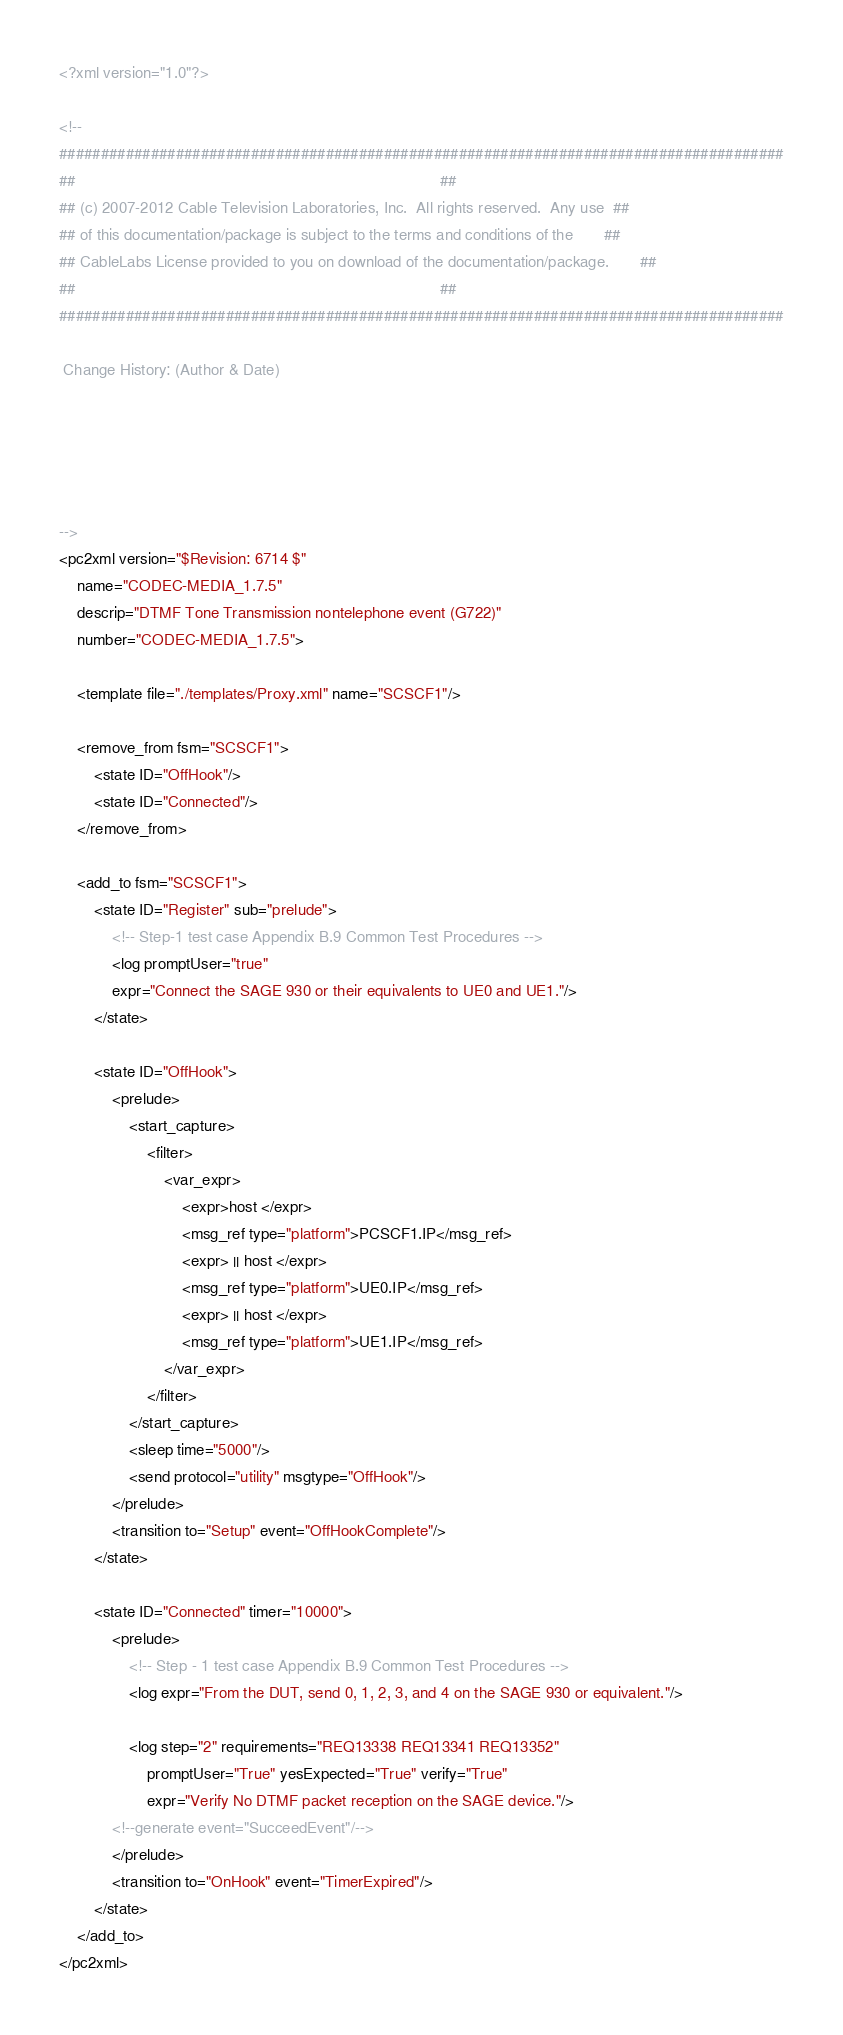Convert code to text. <code><loc_0><loc_0><loc_500><loc_500><_XML_><?xml version="1.0"?>

<!--
#######################################################################################
##                                                                                   ##
## (c) 2007-2012 Cable Television Laboratories, Inc.  All rights reserved.  Any use  ##
## of this documentation/package is subject to the terms and conditions of the       ##
## CableLabs License provided to you on download of the documentation/package.       ##
##                                                                                   ##
#######################################################################################

 Change History: (Author & Date)
	




-->
<pc2xml version="$Revision: 6714 $" 
	name="CODEC-MEDIA_1.7.5" 
	descrip="DTMF Tone Transmission nontelephone event (G722)" 
	number="CODEC-MEDIA_1.7.5">
	
	<template file="./templates/Proxy.xml" name="SCSCF1"/>
	
	<remove_from fsm="SCSCF1">
		<state ID="OffHook"/>
		<state ID="Connected"/>
	</remove_from>
	
	<add_to fsm="SCSCF1">
		<state ID="Register" sub="prelude">
			<!-- Step-1 test case Appendix B.9 Common Test Procedures -->
			<log promptUser="true" 
			expr="Connect the SAGE 930 or their equivalents to UE0 and UE1."/>
		</state>
		
		<state ID="OffHook">
			<prelude>
				<start_capture>
					<filter>
						<var_expr>
							<expr>host </expr>
							<msg_ref type="platform">PCSCF1.IP</msg_ref>
							<expr> || host </expr>
							<msg_ref type="platform">UE0.IP</msg_ref>
							<expr> || host </expr>
							<msg_ref type="platform">UE1.IP</msg_ref>
						</var_expr>
					</filter>
				</start_capture>
				<sleep time="5000"/>
				<send protocol="utility" msgtype="OffHook"/>
			</prelude>
			<transition to="Setup" event="OffHookComplete"/>
		</state>
		
		<state ID="Connected" timer="10000">
			<prelude>
				<!-- Step - 1 test case Appendix B.9 Common Test Procedures -->
				<log expr="From the DUT, send 0, 1, 2, 3, and 4 on the SAGE 930 or equivalent."/>
				
				<log step="2" requirements="REQ13338 REQ13341 REQ13352" 
					promptUser="True" yesExpected="True" verify="True" 
					expr="Verify No DTMF packet reception on the SAGE device."/>
			<!--generate event="SucceedEvent"/-->							
			</prelude>
			<transition to="OnHook" event="TimerExpired"/>
		</state>
	</add_to>
</pc2xml>
</code> 